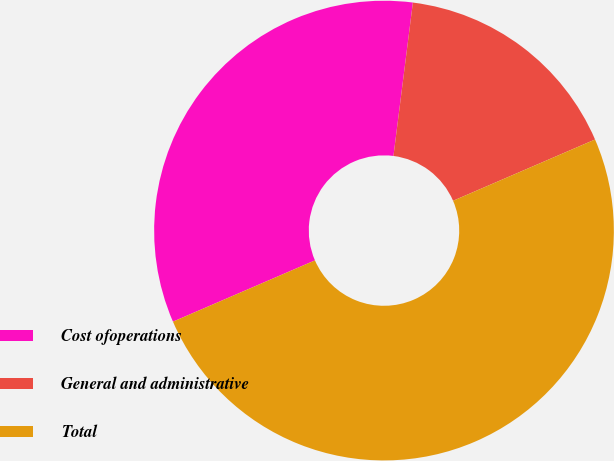Convert chart to OTSL. <chart><loc_0><loc_0><loc_500><loc_500><pie_chart><fcel>Cost ofoperations<fcel>General and administrative<fcel>Total<nl><fcel>33.49%<fcel>16.51%<fcel>50.0%<nl></chart> 